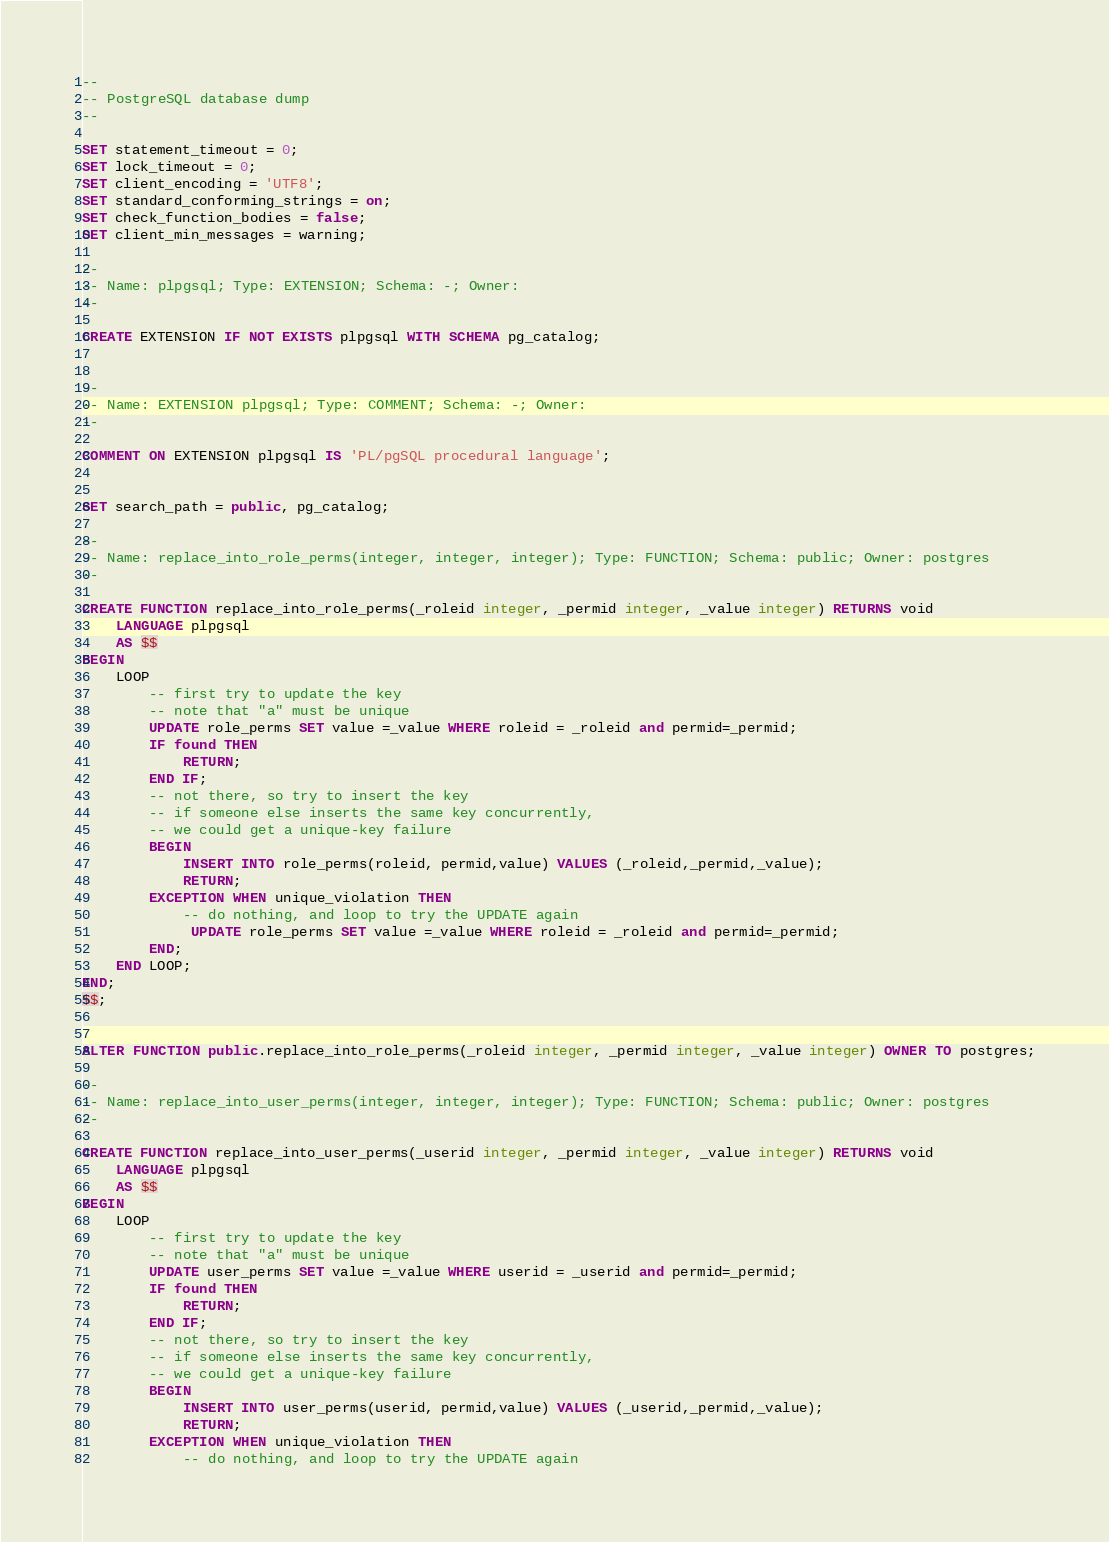Convert code to text. <code><loc_0><loc_0><loc_500><loc_500><_SQL_>--
-- PostgreSQL database dump
--

SET statement_timeout = 0;
SET lock_timeout = 0;
SET client_encoding = 'UTF8';
SET standard_conforming_strings = on;
SET check_function_bodies = false;
SET client_min_messages = warning;

--
-- Name: plpgsql; Type: EXTENSION; Schema: -; Owner: 
--

CREATE EXTENSION IF NOT EXISTS plpgsql WITH SCHEMA pg_catalog;


--
-- Name: EXTENSION plpgsql; Type: COMMENT; Schema: -; Owner: 
--

COMMENT ON EXTENSION plpgsql IS 'PL/pgSQL procedural language';


SET search_path = public, pg_catalog;

--
-- Name: replace_into_role_perms(integer, integer, integer); Type: FUNCTION; Schema: public; Owner: postgres
--

CREATE FUNCTION replace_into_role_perms(_roleid integer, _permid integer, _value integer) RETURNS void
    LANGUAGE plpgsql
    AS $$
BEGIN
    LOOP
        -- first try to update the key
        -- note that "a" must be unique
        UPDATE role_perms SET value =_value WHERE roleid = _roleid and permid=_permid;
        IF found THEN
            RETURN;
        END IF;
        -- not there, so try to insert the key
        -- if someone else inserts the same key concurrently,
        -- we could get a unique-key failure
        BEGIN
            INSERT INTO role_perms(roleid, permid,value) VALUES (_roleid,_permid,_value);
            RETURN;
        EXCEPTION WHEN unique_violation THEN
            -- do nothing, and loop to try the UPDATE again
             UPDATE role_perms SET value =_value WHERE roleid = _roleid and permid=_permid;
        END;
    END LOOP;
END;
$$;


ALTER FUNCTION public.replace_into_role_perms(_roleid integer, _permid integer, _value integer) OWNER TO postgres;

--
-- Name: replace_into_user_perms(integer, integer, integer); Type: FUNCTION; Schema: public; Owner: postgres
--

CREATE FUNCTION replace_into_user_perms(_userid integer, _permid integer, _value integer) RETURNS void
    LANGUAGE plpgsql
    AS $$
BEGIN
    LOOP
        -- first try to update the key
        -- note that "a" must be unique
        UPDATE user_perms SET value =_value WHERE userid = _userid and permid=_permid;
        IF found THEN
            RETURN;
        END IF;
        -- not there, so try to insert the key
        -- if someone else inserts the same key concurrently,
        -- we could get a unique-key failure
        BEGIN
            INSERT INTO user_perms(userid, permid,value) VALUES (_userid,_permid,_value);
            RETURN;
        EXCEPTION WHEN unique_violation THEN
            -- do nothing, and loop to try the UPDATE again</code> 